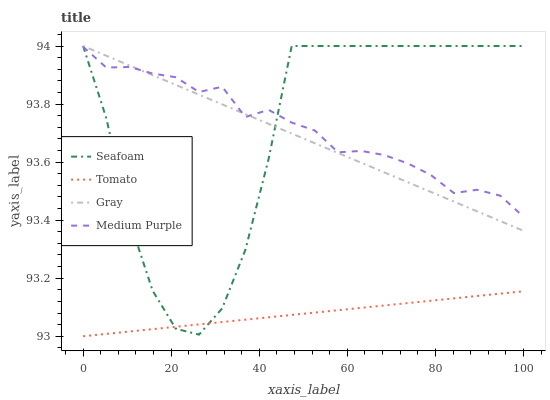Does Tomato have the minimum area under the curve?
Answer yes or no. Yes. Does Medium Purple have the maximum area under the curve?
Answer yes or no. Yes. Does Gray have the minimum area under the curve?
Answer yes or no. No. Does Gray have the maximum area under the curve?
Answer yes or no. No. Is Tomato the smoothest?
Answer yes or no. Yes. Is Seafoam the roughest?
Answer yes or no. Yes. Is Gray the smoothest?
Answer yes or no. No. Is Gray the roughest?
Answer yes or no. No. Does Tomato have the lowest value?
Answer yes or no. Yes. Does Gray have the lowest value?
Answer yes or no. No. Does Seafoam have the highest value?
Answer yes or no. Yes. Does Medium Purple have the highest value?
Answer yes or no. No. Is Tomato less than Medium Purple?
Answer yes or no. Yes. Is Gray greater than Tomato?
Answer yes or no. Yes. Does Seafoam intersect Gray?
Answer yes or no. Yes. Is Seafoam less than Gray?
Answer yes or no. No. Is Seafoam greater than Gray?
Answer yes or no. No. Does Tomato intersect Medium Purple?
Answer yes or no. No. 